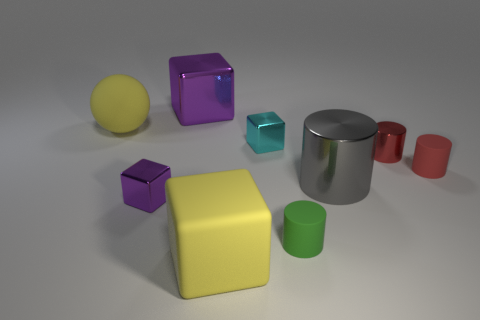Does the large metallic block have the same color as the small metal block in front of the gray shiny thing?
Provide a short and direct response. Yes. The tiny object that is both on the left side of the small red matte cylinder and right of the green object is what color?
Offer a terse response. Red. How many other objects are there of the same material as the tiny green thing?
Your answer should be very brief. 3. Is the number of tiny red matte things less than the number of small blue metal blocks?
Provide a succinct answer. No. Does the green cylinder have the same material as the big object that is left of the large purple metallic block?
Keep it short and to the point. Yes. What is the shape of the yellow rubber object in front of the green cylinder?
Your answer should be very brief. Cube. Are there any other things of the same color as the tiny shiny cylinder?
Make the answer very short. Yes. Is the number of small purple things left of the matte block less than the number of small rubber cylinders?
Keep it short and to the point. Yes. What number of red metallic cylinders are the same size as the red rubber object?
Ensure brevity in your answer.  1. The metal object that is the same color as the large shiny block is what shape?
Your answer should be compact. Cube. 